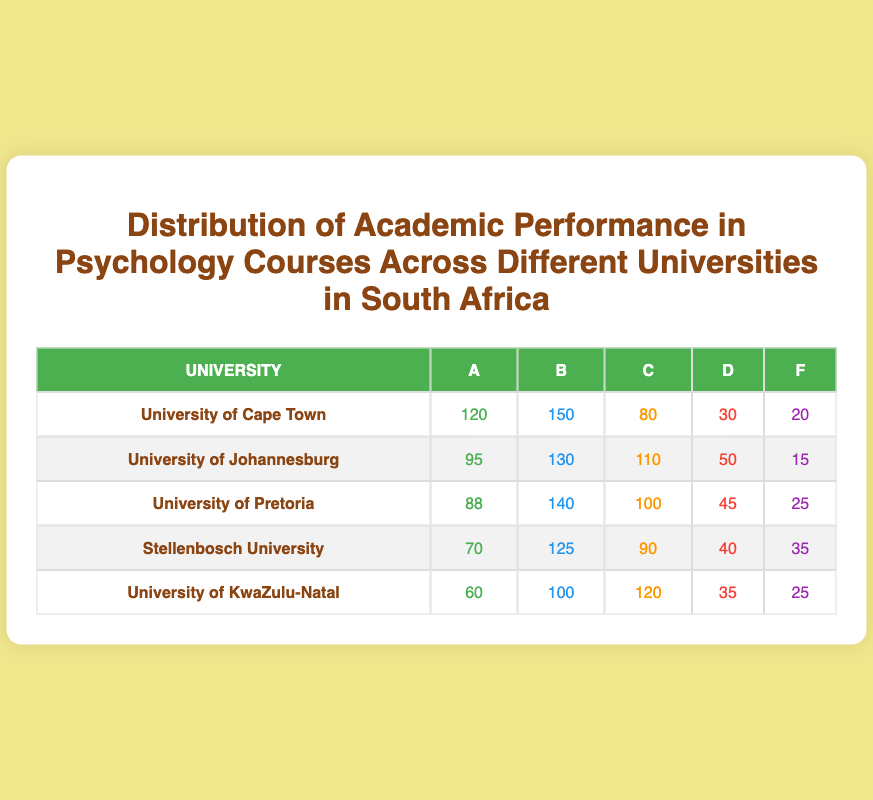What is the highest number of students that received an A grade across the universities? Looking through the A grades for each university, University of Cape Town has the highest number at 120. The A grades are as follows: UCT - 120, UJ - 95, UP - 88, Stellenbosch - 70, and UKZN - 60. The highest among these is 120.
Answer: 120 Which university has the lowest number of students that failed (F grade)? By comparing the F grades from each university, we see the following: UCT - 20, UJ - 15, UP - 25, Stellenbosch - 35, and UKZN - 25. The lowest F grade is 15 from the University of Johannesburg.
Answer: 15 What is the total number of students who received a B grade across all universities? To calculate the total B grades, we add the B grades from each university: 150 (UCT) + 130 (UJ) + 140 (UP) + 125 (Stellenbosch) + 100 (UKZN) = 725. Thus, the total number of students who received a B grade is 725.
Answer: 725 True or False: More students received a C grade in the University of Pretoria than in the University of Cape Town. The number of C grades is listed as follows: UCT - 80, UP - 100. Since 100 (UP) is greater than 80 (UCT), the statement is false.
Answer: False What is the average number of students receiving a D grade across all universities? First, we sum the D grades: 30 (UCT) + 50 (UJ) + 45 (UP) + 40 (Stellenbosch) + 35 (UKZN) = 200. There are 5 universities, so the average is 200/5 = 40.
Answer: 40 